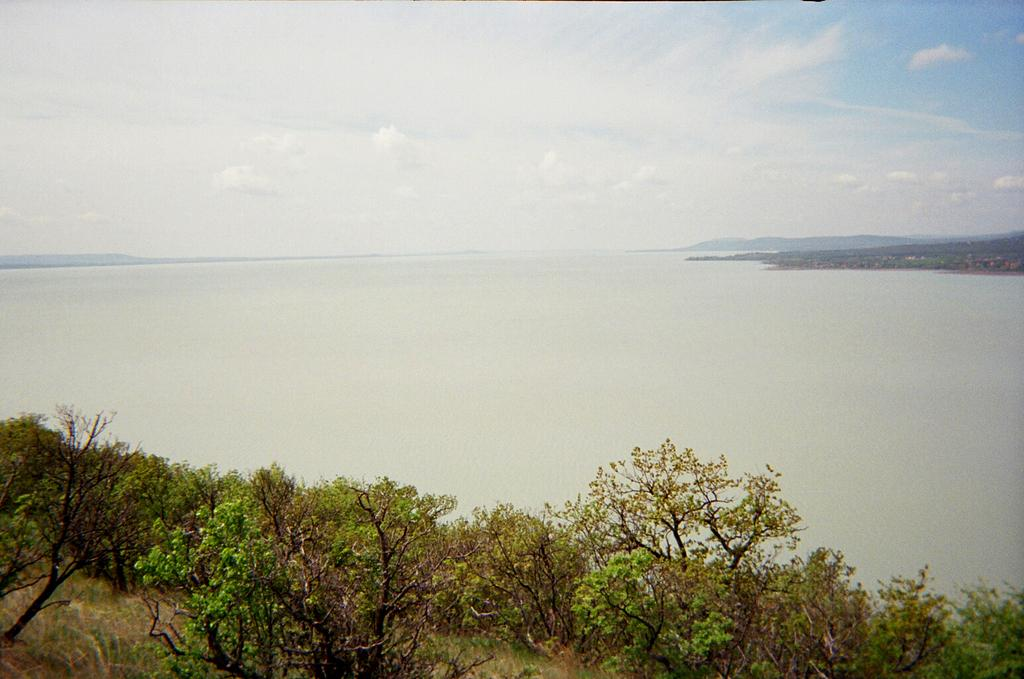What type of vegetation can be seen in the image? There are trees in the image. What natural element is visible in the image? There is water visible in the image. What can be seen in the sky in the image? Clouds are present in the image. What type of throat surgery is being performed in the image? There is no indication of a throat surgery or any medical procedure in the image. Can you tell me how many hospitals are visible in the image? There are no hospitals present in the image. 